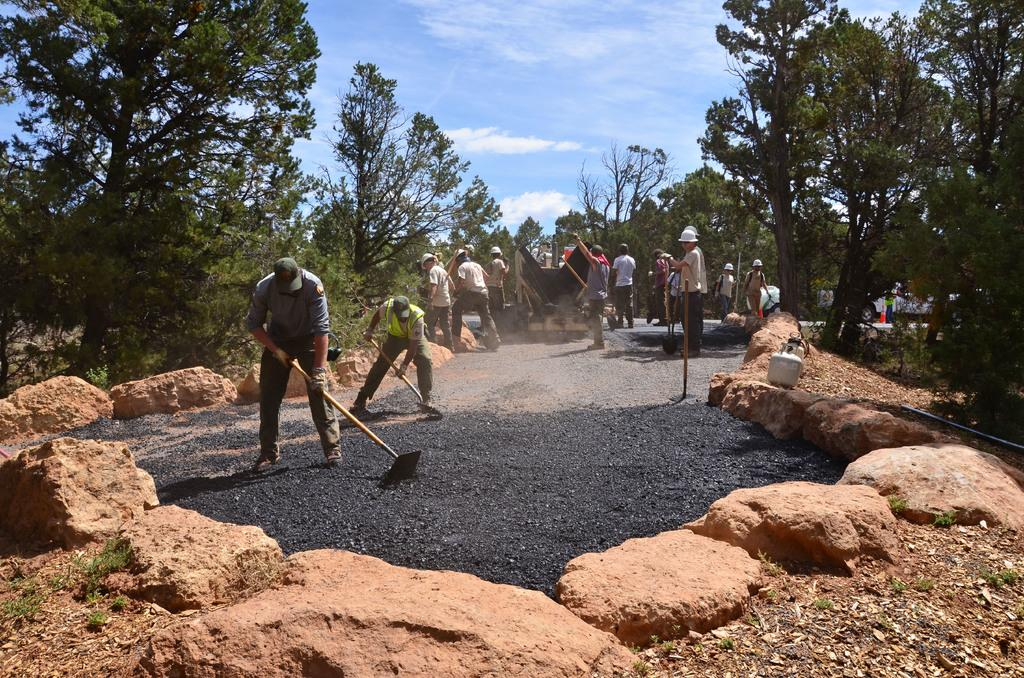How many people are in the image? There are people in the image, but the exact number is not specified. What are some people holding in the image? Some people are holding something, but the specific objects are not mentioned. What types of vehicles can be seen on the road in the image? The types of vehicles on the road are not specified. What kind of vegetation is present in the image? There are trees in the image. What is the texture of the ground in the image? Mud is visible in the image, indicating a potentially soft or wet ground. What other materials are present in the image? Stones are present in the image. What is the color of the sky in the image? The sky is blue and white in color. What is the name of the person standing next to the office in the image? There is no mention of an office or a person's name in the image. What type of nose can be seen on the person in the image? There is no person's nose visible in the image. 